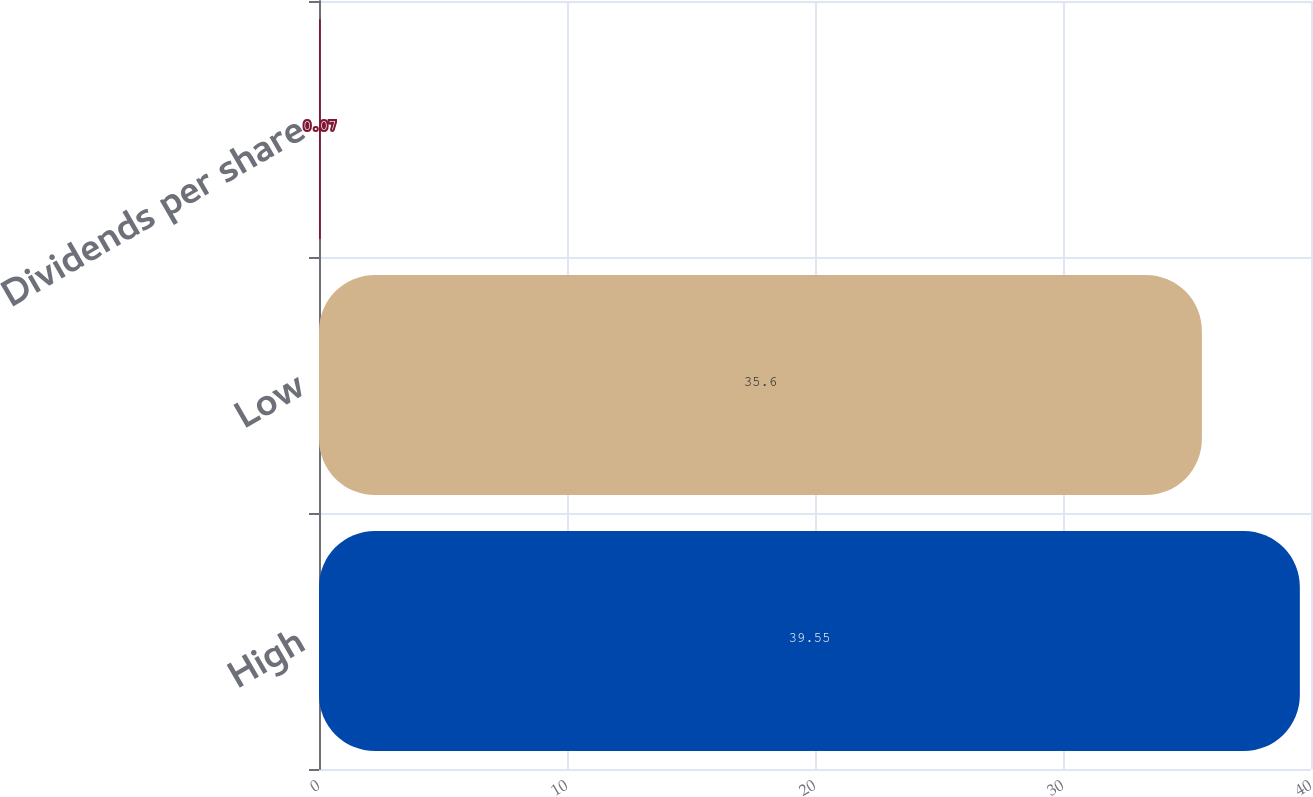<chart> <loc_0><loc_0><loc_500><loc_500><bar_chart><fcel>High<fcel>Low<fcel>Dividends per share<nl><fcel>39.55<fcel>35.6<fcel>0.07<nl></chart> 